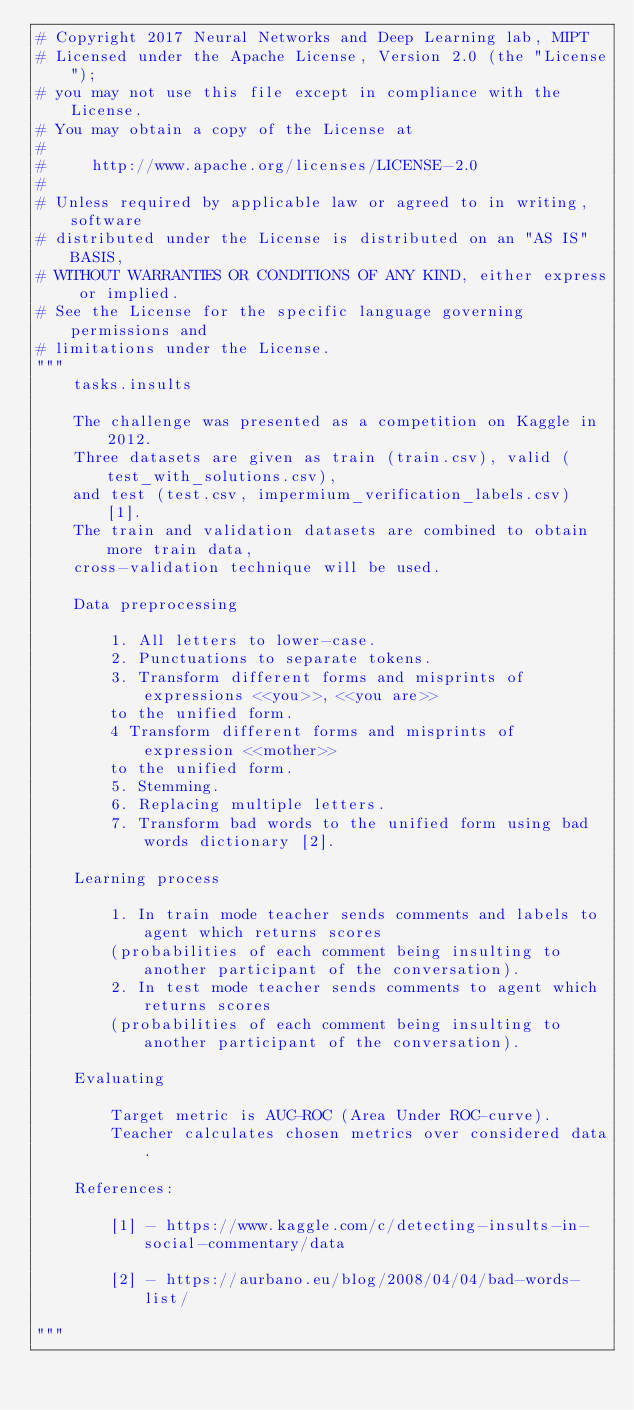<code> <loc_0><loc_0><loc_500><loc_500><_Python_># Copyright 2017 Neural Networks and Deep Learning lab, MIPT
# Licensed under the Apache License, Version 2.0 (the "License");
# you may not use this file except in compliance with the License.
# You may obtain a copy of the License at
#
#     http://www.apache.org/licenses/LICENSE-2.0
#
# Unless required by applicable law or agreed to in writing, software
# distributed under the License is distributed on an "AS IS" BASIS,
# WITHOUT WARRANTIES OR CONDITIONS OF ANY KIND, either express or implied.
# See the License for the specific language governing permissions and
# limitations under the License.
"""
    tasks.insults
    
    The challenge was presented as a competition on Kaggle in 2012.
    Three datasets are given as train (train.csv), valid (test_with_solutions.csv), 
    and test (test.csv, impermium_verification_labels.csv) [1]. 
    The train and validation datasets are combined to obtain more train data,
    cross-validation technique will be used.
        
    Data preprocessing
    
        1. All letters to lower-case.
        2. Punctuations to separate tokens.
        3. Transform different forms and misprints of expressions <<you>>, <<you are>> 
        to the unified form.
        4 Transform different forms and misprints of expression <<mother>> 
        to the unified form.
        5. Stemming.
        6. Replacing multiple letters.
        7. Transform bad words to the unified form using bad words dictionary [2].
        
    Learning process
    
        1. In train mode teacher sends comments and labels to agent which returns scores 
        (probabilities of each comment being insulting to another participant of the conversation).
        2. In test mode teacher sends comments to agent which returns scores 
        (probabilities of each comment being insulting to another participant of the conversation).
        
    Evaluating
        
        Target metric is AUC-ROC (Area Under ROC-curve).
        Teacher calculates chosen metrics over considered data.

    References:
    
        [1] - https://www.kaggle.com/c/detecting-insults-in-social-commentary/data
        
        [2] - https://aurbano.eu/blog/2008/04/04/bad-words-list/
        
"""</code> 